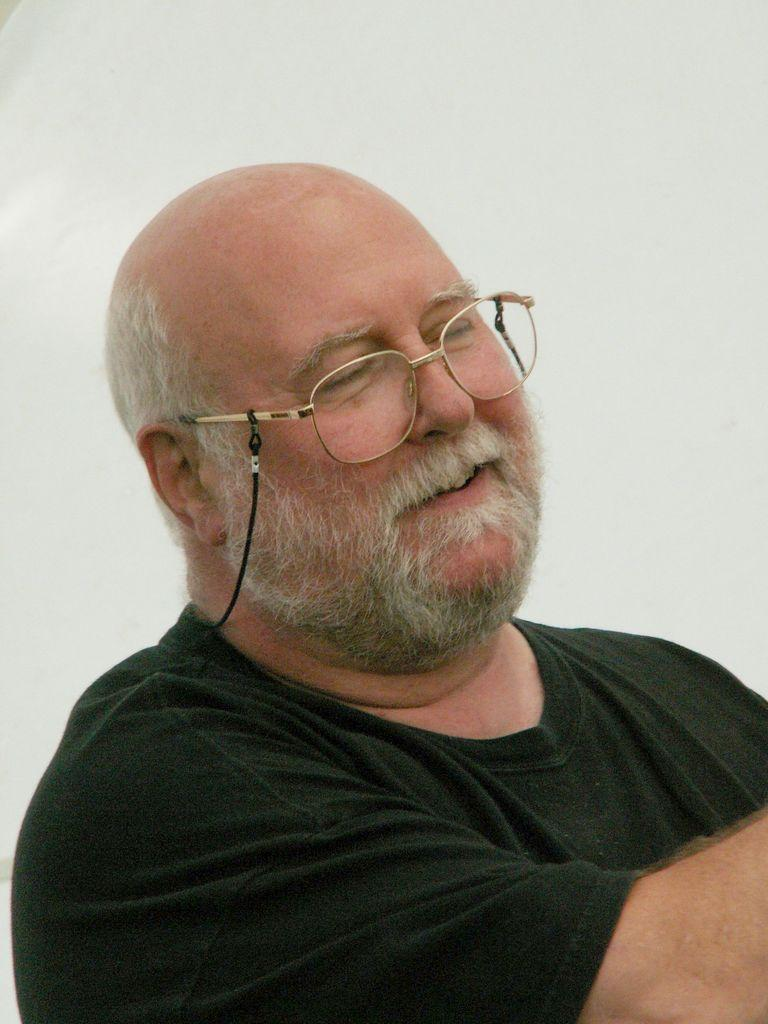Who is the main subject in the image? There is an old man in the image. What is the old man wearing on his upper body? The old man is wearing a black t-shirt. What type of eyewear is the old man wearing? The old man is wearing gold-colored spectacles. What color crayon is the old man using to draw in the image? There is no crayon present in the image, and the old man is not drawing. 